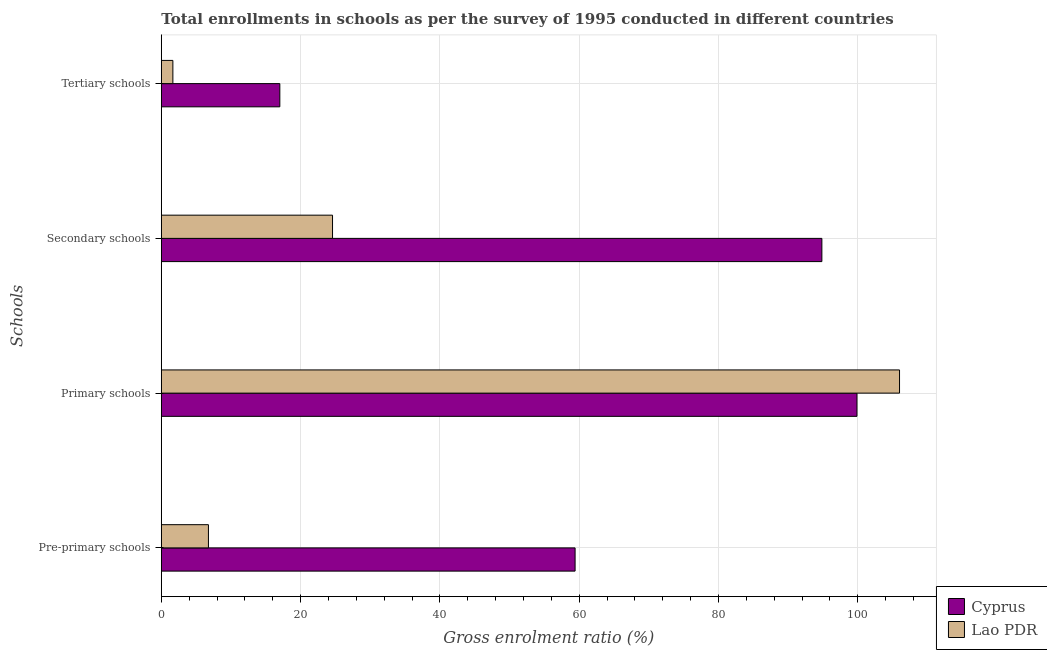How many different coloured bars are there?
Provide a succinct answer. 2. How many groups of bars are there?
Provide a succinct answer. 4. How many bars are there on the 4th tick from the bottom?
Give a very brief answer. 2. What is the label of the 2nd group of bars from the top?
Offer a terse response. Secondary schools. What is the gross enrolment ratio in primary schools in Lao PDR?
Your response must be concise. 106. Across all countries, what is the maximum gross enrolment ratio in tertiary schools?
Provide a succinct answer. 17.02. Across all countries, what is the minimum gross enrolment ratio in primary schools?
Keep it short and to the point. 99.88. In which country was the gross enrolment ratio in pre-primary schools maximum?
Ensure brevity in your answer.  Cyprus. In which country was the gross enrolment ratio in secondary schools minimum?
Your answer should be compact. Lao PDR. What is the total gross enrolment ratio in secondary schools in the graph?
Give a very brief answer. 119.43. What is the difference between the gross enrolment ratio in primary schools in Lao PDR and that in Cyprus?
Your answer should be very brief. 6.11. What is the difference between the gross enrolment ratio in primary schools in Cyprus and the gross enrolment ratio in tertiary schools in Lao PDR?
Your answer should be compact. 98.23. What is the average gross enrolment ratio in secondary schools per country?
Offer a very short reply. 59.71. What is the difference between the gross enrolment ratio in primary schools and gross enrolment ratio in secondary schools in Cyprus?
Your answer should be very brief. 5.04. What is the ratio of the gross enrolment ratio in primary schools in Lao PDR to that in Cyprus?
Provide a short and direct response. 1.06. Is the difference between the gross enrolment ratio in primary schools in Lao PDR and Cyprus greater than the difference between the gross enrolment ratio in secondary schools in Lao PDR and Cyprus?
Offer a terse response. Yes. What is the difference between the highest and the second highest gross enrolment ratio in pre-primary schools?
Ensure brevity in your answer.  52.65. What is the difference between the highest and the lowest gross enrolment ratio in primary schools?
Ensure brevity in your answer.  6.11. In how many countries, is the gross enrolment ratio in pre-primary schools greater than the average gross enrolment ratio in pre-primary schools taken over all countries?
Give a very brief answer. 1. What does the 2nd bar from the top in Secondary schools represents?
Give a very brief answer. Cyprus. What does the 2nd bar from the bottom in Secondary schools represents?
Offer a very short reply. Lao PDR. Does the graph contain any zero values?
Make the answer very short. No. Does the graph contain grids?
Give a very brief answer. Yes. How many legend labels are there?
Keep it short and to the point. 2. What is the title of the graph?
Offer a terse response. Total enrollments in schools as per the survey of 1995 conducted in different countries. Does "Croatia" appear as one of the legend labels in the graph?
Offer a very short reply. No. What is the label or title of the X-axis?
Give a very brief answer. Gross enrolment ratio (%). What is the label or title of the Y-axis?
Your answer should be compact. Schools. What is the Gross enrolment ratio (%) in Cyprus in Pre-primary schools?
Your response must be concise. 59.41. What is the Gross enrolment ratio (%) in Lao PDR in Pre-primary schools?
Provide a succinct answer. 6.77. What is the Gross enrolment ratio (%) in Cyprus in Primary schools?
Make the answer very short. 99.88. What is the Gross enrolment ratio (%) in Lao PDR in Primary schools?
Offer a terse response. 106. What is the Gross enrolment ratio (%) in Cyprus in Secondary schools?
Give a very brief answer. 94.85. What is the Gross enrolment ratio (%) of Lao PDR in Secondary schools?
Keep it short and to the point. 24.58. What is the Gross enrolment ratio (%) of Cyprus in Tertiary schools?
Your response must be concise. 17.02. What is the Gross enrolment ratio (%) of Lao PDR in Tertiary schools?
Ensure brevity in your answer.  1.66. Across all Schools, what is the maximum Gross enrolment ratio (%) of Cyprus?
Offer a terse response. 99.88. Across all Schools, what is the maximum Gross enrolment ratio (%) in Lao PDR?
Provide a short and direct response. 106. Across all Schools, what is the minimum Gross enrolment ratio (%) in Cyprus?
Give a very brief answer. 17.02. Across all Schools, what is the minimum Gross enrolment ratio (%) in Lao PDR?
Give a very brief answer. 1.66. What is the total Gross enrolment ratio (%) of Cyprus in the graph?
Your answer should be compact. 271.16. What is the total Gross enrolment ratio (%) of Lao PDR in the graph?
Give a very brief answer. 139.01. What is the difference between the Gross enrolment ratio (%) in Cyprus in Pre-primary schools and that in Primary schools?
Your answer should be compact. -40.47. What is the difference between the Gross enrolment ratio (%) of Lao PDR in Pre-primary schools and that in Primary schools?
Your answer should be very brief. -99.23. What is the difference between the Gross enrolment ratio (%) in Cyprus in Pre-primary schools and that in Secondary schools?
Offer a very short reply. -35.43. What is the difference between the Gross enrolment ratio (%) in Lao PDR in Pre-primary schools and that in Secondary schools?
Keep it short and to the point. -17.82. What is the difference between the Gross enrolment ratio (%) of Cyprus in Pre-primary schools and that in Tertiary schools?
Your answer should be very brief. 42.39. What is the difference between the Gross enrolment ratio (%) of Lao PDR in Pre-primary schools and that in Tertiary schools?
Provide a short and direct response. 5.11. What is the difference between the Gross enrolment ratio (%) of Cyprus in Primary schools and that in Secondary schools?
Your response must be concise. 5.04. What is the difference between the Gross enrolment ratio (%) in Lao PDR in Primary schools and that in Secondary schools?
Provide a short and direct response. 81.41. What is the difference between the Gross enrolment ratio (%) in Cyprus in Primary schools and that in Tertiary schools?
Your answer should be compact. 82.87. What is the difference between the Gross enrolment ratio (%) in Lao PDR in Primary schools and that in Tertiary schools?
Your answer should be compact. 104.34. What is the difference between the Gross enrolment ratio (%) of Cyprus in Secondary schools and that in Tertiary schools?
Your response must be concise. 77.83. What is the difference between the Gross enrolment ratio (%) in Lao PDR in Secondary schools and that in Tertiary schools?
Provide a short and direct response. 22.92. What is the difference between the Gross enrolment ratio (%) of Cyprus in Pre-primary schools and the Gross enrolment ratio (%) of Lao PDR in Primary schools?
Provide a succinct answer. -46.58. What is the difference between the Gross enrolment ratio (%) of Cyprus in Pre-primary schools and the Gross enrolment ratio (%) of Lao PDR in Secondary schools?
Ensure brevity in your answer.  34.83. What is the difference between the Gross enrolment ratio (%) of Cyprus in Pre-primary schools and the Gross enrolment ratio (%) of Lao PDR in Tertiary schools?
Keep it short and to the point. 57.75. What is the difference between the Gross enrolment ratio (%) in Cyprus in Primary schools and the Gross enrolment ratio (%) in Lao PDR in Secondary schools?
Ensure brevity in your answer.  75.3. What is the difference between the Gross enrolment ratio (%) in Cyprus in Primary schools and the Gross enrolment ratio (%) in Lao PDR in Tertiary schools?
Keep it short and to the point. 98.23. What is the difference between the Gross enrolment ratio (%) in Cyprus in Secondary schools and the Gross enrolment ratio (%) in Lao PDR in Tertiary schools?
Offer a very short reply. 93.19. What is the average Gross enrolment ratio (%) of Cyprus per Schools?
Ensure brevity in your answer.  67.79. What is the average Gross enrolment ratio (%) in Lao PDR per Schools?
Ensure brevity in your answer.  34.75. What is the difference between the Gross enrolment ratio (%) of Cyprus and Gross enrolment ratio (%) of Lao PDR in Pre-primary schools?
Your answer should be compact. 52.65. What is the difference between the Gross enrolment ratio (%) of Cyprus and Gross enrolment ratio (%) of Lao PDR in Primary schools?
Provide a succinct answer. -6.11. What is the difference between the Gross enrolment ratio (%) of Cyprus and Gross enrolment ratio (%) of Lao PDR in Secondary schools?
Provide a short and direct response. 70.26. What is the difference between the Gross enrolment ratio (%) of Cyprus and Gross enrolment ratio (%) of Lao PDR in Tertiary schools?
Your answer should be compact. 15.36. What is the ratio of the Gross enrolment ratio (%) of Cyprus in Pre-primary schools to that in Primary schools?
Keep it short and to the point. 0.59. What is the ratio of the Gross enrolment ratio (%) of Lao PDR in Pre-primary schools to that in Primary schools?
Provide a short and direct response. 0.06. What is the ratio of the Gross enrolment ratio (%) in Cyprus in Pre-primary schools to that in Secondary schools?
Your answer should be very brief. 0.63. What is the ratio of the Gross enrolment ratio (%) in Lao PDR in Pre-primary schools to that in Secondary schools?
Keep it short and to the point. 0.28. What is the ratio of the Gross enrolment ratio (%) of Cyprus in Pre-primary schools to that in Tertiary schools?
Provide a succinct answer. 3.49. What is the ratio of the Gross enrolment ratio (%) of Lao PDR in Pre-primary schools to that in Tertiary schools?
Offer a very short reply. 4.08. What is the ratio of the Gross enrolment ratio (%) in Cyprus in Primary schools to that in Secondary schools?
Your answer should be compact. 1.05. What is the ratio of the Gross enrolment ratio (%) in Lao PDR in Primary schools to that in Secondary schools?
Provide a short and direct response. 4.31. What is the ratio of the Gross enrolment ratio (%) of Cyprus in Primary schools to that in Tertiary schools?
Make the answer very short. 5.87. What is the ratio of the Gross enrolment ratio (%) in Lao PDR in Primary schools to that in Tertiary schools?
Offer a terse response. 63.88. What is the ratio of the Gross enrolment ratio (%) in Cyprus in Secondary schools to that in Tertiary schools?
Your answer should be very brief. 5.57. What is the ratio of the Gross enrolment ratio (%) of Lao PDR in Secondary schools to that in Tertiary schools?
Provide a short and direct response. 14.82. What is the difference between the highest and the second highest Gross enrolment ratio (%) of Cyprus?
Give a very brief answer. 5.04. What is the difference between the highest and the second highest Gross enrolment ratio (%) of Lao PDR?
Your answer should be compact. 81.41. What is the difference between the highest and the lowest Gross enrolment ratio (%) of Cyprus?
Your answer should be very brief. 82.87. What is the difference between the highest and the lowest Gross enrolment ratio (%) of Lao PDR?
Your answer should be very brief. 104.34. 